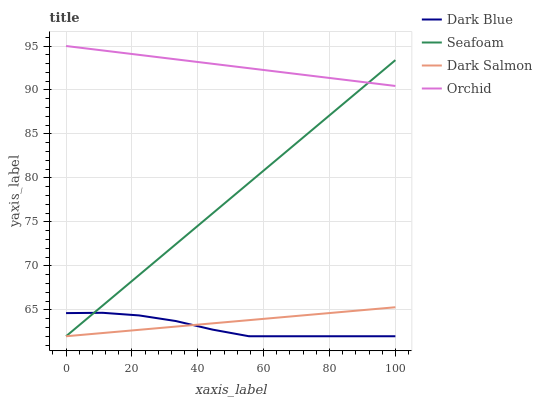Does Dark Blue have the minimum area under the curve?
Answer yes or no. Yes. Does Orchid have the maximum area under the curve?
Answer yes or no. Yes. Does Seafoam have the minimum area under the curve?
Answer yes or no. No. Does Seafoam have the maximum area under the curve?
Answer yes or no. No. Is Seafoam the smoothest?
Answer yes or no. Yes. Is Dark Blue the roughest?
Answer yes or no. Yes. Is Orchid the smoothest?
Answer yes or no. No. Is Orchid the roughest?
Answer yes or no. No. Does Dark Blue have the lowest value?
Answer yes or no. Yes. Does Orchid have the lowest value?
Answer yes or no. No. Does Orchid have the highest value?
Answer yes or no. Yes. Does Seafoam have the highest value?
Answer yes or no. No. Is Dark Blue less than Orchid?
Answer yes or no. Yes. Is Orchid greater than Dark Salmon?
Answer yes or no. Yes. Does Dark Salmon intersect Dark Blue?
Answer yes or no. Yes. Is Dark Salmon less than Dark Blue?
Answer yes or no. No. Is Dark Salmon greater than Dark Blue?
Answer yes or no. No. Does Dark Blue intersect Orchid?
Answer yes or no. No. 